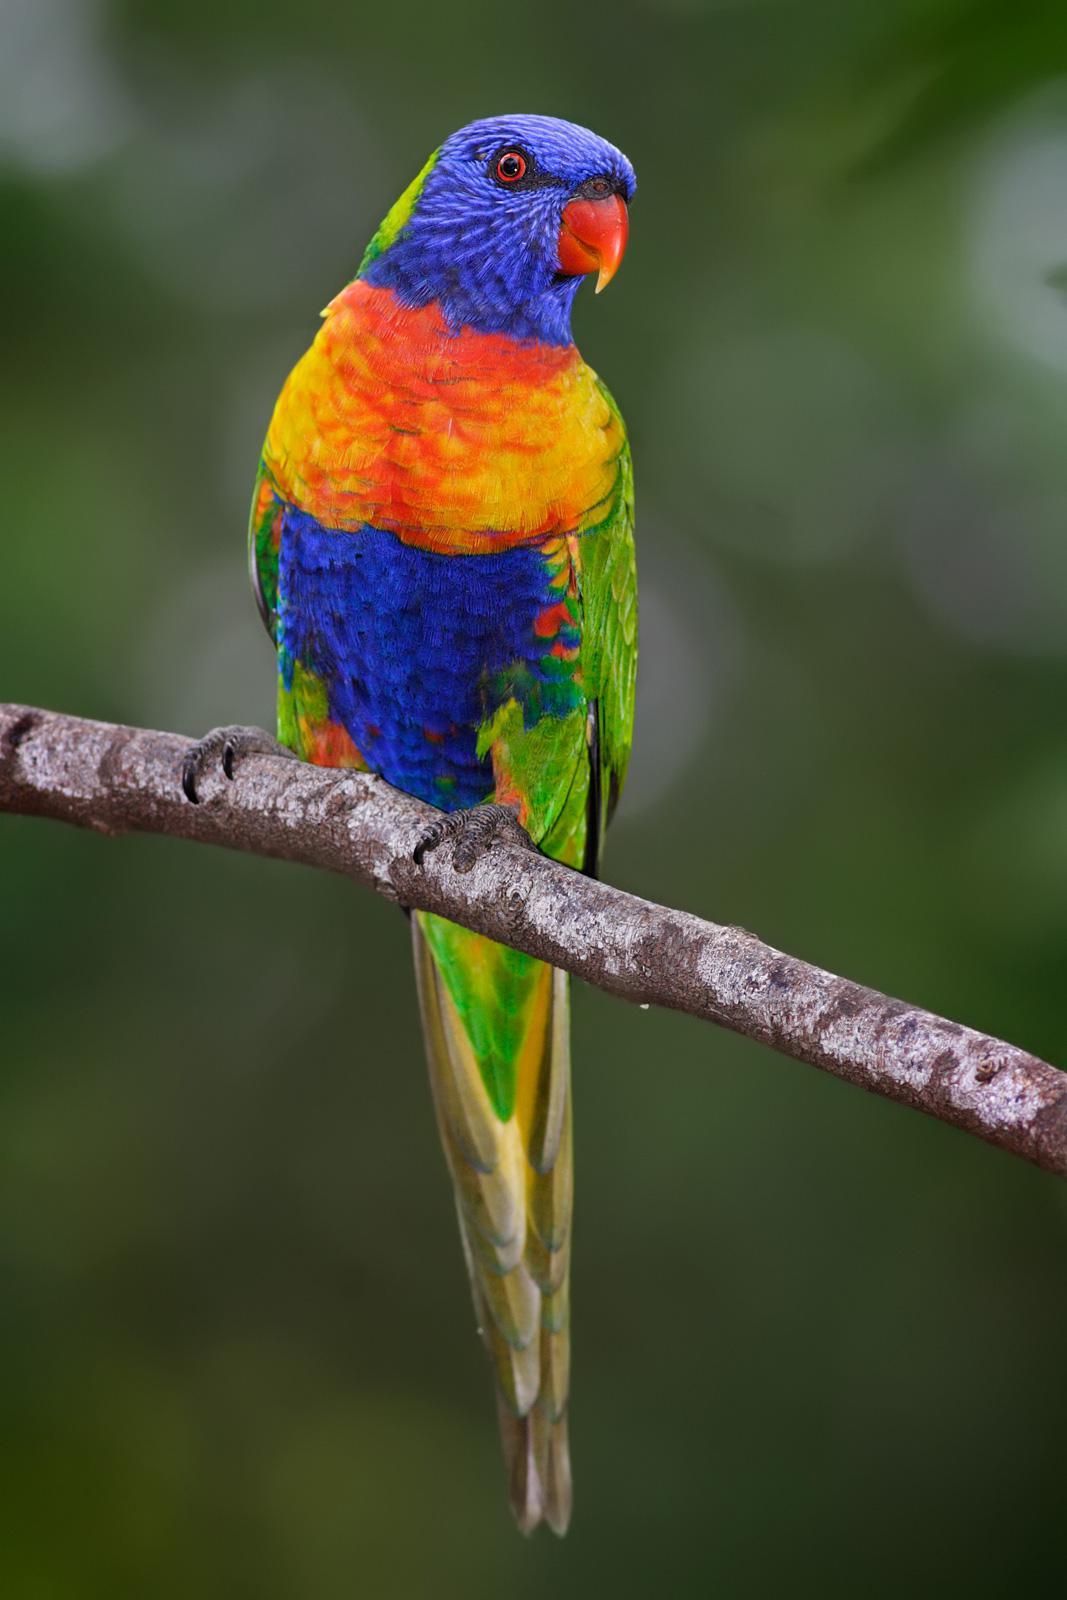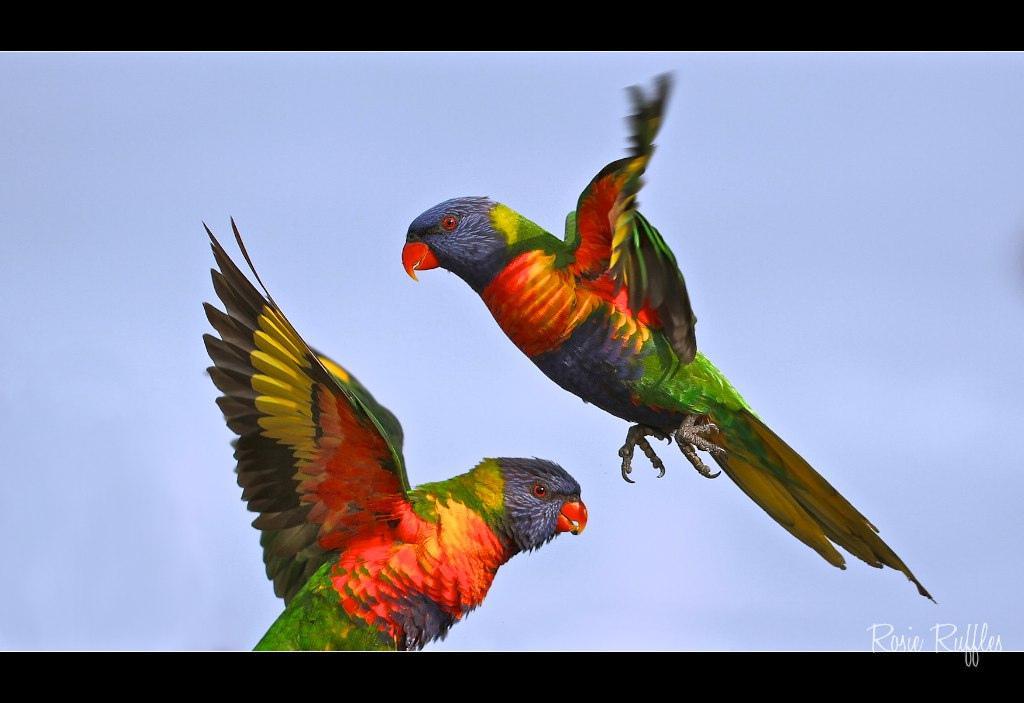The first image is the image on the left, the second image is the image on the right. Analyze the images presented: Is the assertion "Both images show a parrot that is flying" valid? Answer yes or no. No. The first image is the image on the left, the second image is the image on the right. Given the left and right images, does the statement "Only parrots in flight are shown in the images." hold true? Answer yes or no. No. 